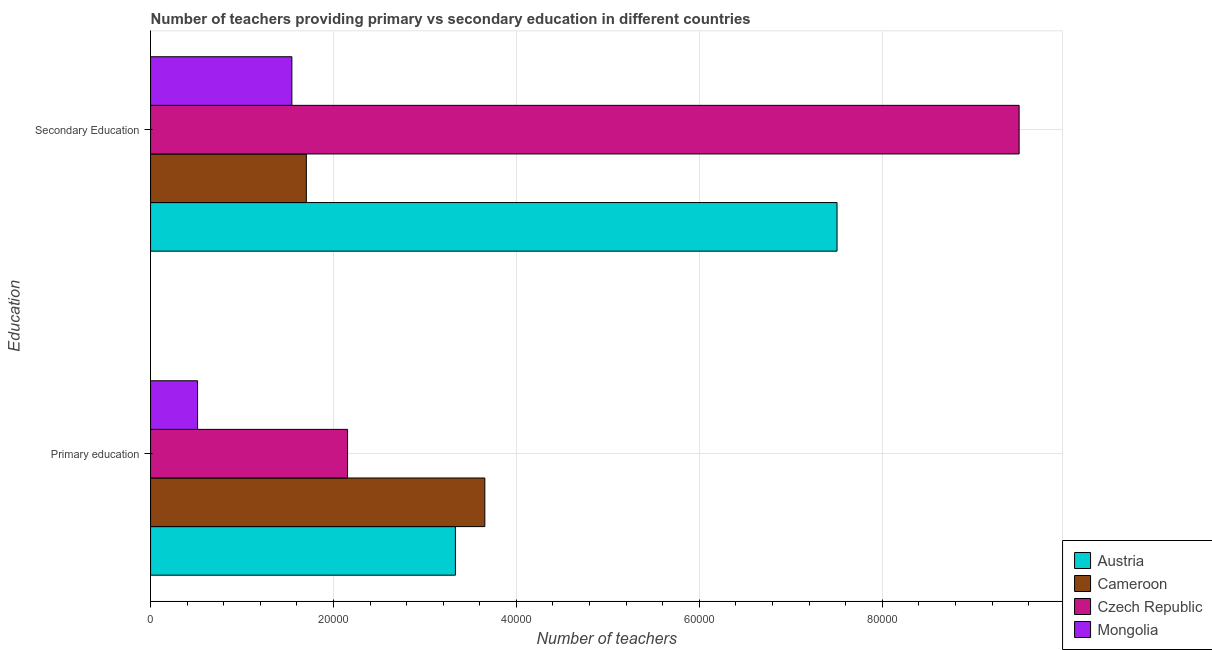How many different coloured bars are there?
Offer a terse response. 4. How many bars are there on the 2nd tick from the top?
Offer a very short reply. 4. How many bars are there on the 2nd tick from the bottom?
Make the answer very short. 4. What is the label of the 1st group of bars from the top?
Give a very brief answer. Secondary Education. What is the number of primary teachers in Czech Republic?
Provide a short and direct response. 2.15e+04. Across all countries, what is the maximum number of primary teachers?
Give a very brief answer. 3.65e+04. Across all countries, what is the minimum number of secondary teachers?
Provide a short and direct response. 1.54e+04. In which country was the number of primary teachers maximum?
Keep it short and to the point. Cameroon. In which country was the number of secondary teachers minimum?
Make the answer very short. Mongolia. What is the total number of primary teachers in the graph?
Provide a short and direct response. 9.66e+04. What is the difference between the number of secondary teachers in Mongolia and that in Czech Republic?
Ensure brevity in your answer.  -7.95e+04. What is the difference between the number of secondary teachers in Austria and the number of primary teachers in Mongolia?
Give a very brief answer. 6.99e+04. What is the average number of secondary teachers per country?
Provide a succinct answer. 5.06e+04. What is the difference between the number of primary teachers and number of secondary teachers in Mongolia?
Provide a succinct answer. -1.03e+04. In how many countries, is the number of secondary teachers greater than 36000 ?
Offer a terse response. 2. What is the ratio of the number of secondary teachers in Austria to that in Mongolia?
Offer a very short reply. 4.86. Is the number of primary teachers in Czech Republic less than that in Mongolia?
Provide a short and direct response. No. What does the 3rd bar from the top in Primary education represents?
Offer a very short reply. Cameroon. What does the 1st bar from the bottom in Primary education represents?
Ensure brevity in your answer.  Austria. What is the difference between two consecutive major ticks on the X-axis?
Make the answer very short. 2.00e+04. Are the values on the major ticks of X-axis written in scientific E-notation?
Offer a very short reply. No. How many legend labels are there?
Make the answer very short. 4. How are the legend labels stacked?
Give a very brief answer. Vertical. What is the title of the graph?
Your answer should be very brief. Number of teachers providing primary vs secondary education in different countries. What is the label or title of the X-axis?
Keep it short and to the point. Number of teachers. What is the label or title of the Y-axis?
Make the answer very short. Education. What is the Number of teachers of Austria in Primary education?
Offer a terse response. 3.33e+04. What is the Number of teachers in Cameroon in Primary education?
Keep it short and to the point. 3.65e+04. What is the Number of teachers of Czech Republic in Primary education?
Give a very brief answer. 2.15e+04. What is the Number of teachers in Mongolia in Primary education?
Keep it short and to the point. 5140. What is the Number of teachers of Austria in Secondary Education?
Provide a succinct answer. 7.51e+04. What is the Number of teachers of Cameroon in Secondary Education?
Give a very brief answer. 1.70e+04. What is the Number of teachers of Czech Republic in Secondary Education?
Provide a short and direct response. 9.50e+04. What is the Number of teachers in Mongolia in Secondary Education?
Keep it short and to the point. 1.54e+04. Across all Education, what is the maximum Number of teachers in Austria?
Keep it short and to the point. 7.51e+04. Across all Education, what is the maximum Number of teachers of Cameroon?
Offer a very short reply. 3.65e+04. Across all Education, what is the maximum Number of teachers in Czech Republic?
Give a very brief answer. 9.50e+04. Across all Education, what is the maximum Number of teachers in Mongolia?
Your answer should be compact. 1.54e+04. Across all Education, what is the minimum Number of teachers in Austria?
Your answer should be very brief. 3.33e+04. Across all Education, what is the minimum Number of teachers in Cameroon?
Offer a terse response. 1.70e+04. Across all Education, what is the minimum Number of teachers of Czech Republic?
Your response must be concise. 2.15e+04. Across all Education, what is the minimum Number of teachers in Mongolia?
Offer a very short reply. 5140. What is the total Number of teachers in Austria in the graph?
Give a very brief answer. 1.08e+05. What is the total Number of teachers in Cameroon in the graph?
Your answer should be very brief. 5.36e+04. What is the total Number of teachers in Czech Republic in the graph?
Your response must be concise. 1.17e+05. What is the total Number of teachers of Mongolia in the graph?
Ensure brevity in your answer.  2.06e+04. What is the difference between the Number of teachers of Austria in Primary education and that in Secondary Education?
Offer a terse response. -4.17e+04. What is the difference between the Number of teachers of Cameroon in Primary education and that in Secondary Education?
Give a very brief answer. 1.95e+04. What is the difference between the Number of teachers in Czech Republic in Primary education and that in Secondary Education?
Your response must be concise. -7.34e+04. What is the difference between the Number of teachers of Mongolia in Primary education and that in Secondary Education?
Provide a short and direct response. -1.03e+04. What is the difference between the Number of teachers in Austria in Primary education and the Number of teachers in Cameroon in Secondary Education?
Offer a very short reply. 1.63e+04. What is the difference between the Number of teachers in Austria in Primary education and the Number of teachers in Czech Republic in Secondary Education?
Ensure brevity in your answer.  -6.16e+04. What is the difference between the Number of teachers of Austria in Primary education and the Number of teachers of Mongolia in Secondary Education?
Keep it short and to the point. 1.79e+04. What is the difference between the Number of teachers in Cameroon in Primary education and the Number of teachers in Czech Republic in Secondary Education?
Your answer should be compact. -5.84e+04. What is the difference between the Number of teachers in Cameroon in Primary education and the Number of teachers in Mongolia in Secondary Education?
Keep it short and to the point. 2.11e+04. What is the difference between the Number of teachers of Czech Republic in Primary education and the Number of teachers of Mongolia in Secondary Education?
Your response must be concise. 6089. What is the average Number of teachers of Austria per Education?
Offer a terse response. 5.42e+04. What is the average Number of teachers in Cameroon per Education?
Your answer should be very brief. 2.68e+04. What is the average Number of teachers in Czech Republic per Education?
Provide a short and direct response. 5.83e+04. What is the average Number of teachers in Mongolia per Education?
Give a very brief answer. 1.03e+04. What is the difference between the Number of teachers in Austria and Number of teachers in Cameroon in Primary education?
Your response must be concise. -3218. What is the difference between the Number of teachers in Austria and Number of teachers in Czech Republic in Primary education?
Give a very brief answer. 1.18e+04. What is the difference between the Number of teachers of Austria and Number of teachers of Mongolia in Primary education?
Keep it short and to the point. 2.82e+04. What is the difference between the Number of teachers of Cameroon and Number of teachers of Czech Republic in Primary education?
Offer a terse response. 1.50e+04. What is the difference between the Number of teachers of Cameroon and Number of teachers of Mongolia in Primary education?
Offer a terse response. 3.14e+04. What is the difference between the Number of teachers in Czech Republic and Number of teachers in Mongolia in Primary education?
Ensure brevity in your answer.  1.64e+04. What is the difference between the Number of teachers of Austria and Number of teachers of Cameroon in Secondary Education?
Make the answer very short. 5.80e+04. What is the difference between the Number of teachers in Austria and Number of teachers in Czech Republic in Secondary Education?
Your response must be concise. -1.99e+04. What is the difference between the Number of teachers in Austria and Number of teachers in Mongolia in Secondary Education?
Provide a succinct answer. 5.96e+04. What is the difference between the Number of teachers of Cameroon and Number of teachers of Czech Republic in Secondary Education?
Keep it short and to the point. -7.79e+04. What is the difference between the Number of teachers of Cameroon and Number of teachers of Mongolia in Secondary Education?
Give a very brief answer. 1582. What is the difference between the Number of teachers in Czech Republic and Number of teachers in Mongolia in Secondary Education?
Ensure brevity in your answer.  7.95e+04. What is the ratio of the Number of teachers in Austria in Primary education to that in Secondary Education?
Keep it short and to the point. 0.44. What is the ratio of the Number of teachers in Cameroon in Primary education to that in Secondary Education?
Your answer should be compact. 2.15. What is the ratio of the Number of teachers in Czech Republic in Primary education to that in Secondary Education?
Give a very brief answer. 0.23. What is the ratio of the Number of teachers of Mongolia in Primary education to that in Secondary Education?
Offer a terse response. 0.33. What is the difference between the highest and the second highest Number of teachers in Austria?
Give a very brief answer. 4.17e+04. What is the difference between the highest and the second highest Number of teachers of Cameroon?
Offer a terse response. 1.95e+04. What is the difference between the highest and the second highest Number of teachers in Czech Republic?
Give a very brief answer. 7.34e+04. What is the difference between the highest and the second highest Number of teachers of Mongolia?
Offer a very short reply. 1.03e+04. What is the difference between the highest and the lowest Number of teachers of Austria?
Your answer should be very brief. 4.17e+04. What is the difference between the highest and the lowest Number of teachers in Cameroon?
Offer a very short reply. 1.95e+04. What is the difference between the highest and the lowest Number of teachers of Czech Republic?
Your answer should be very brief. 7.34e+04. What is the difference between the highest and the lowest Number of teachers in Mongolia?
Your response must be concise. 1.03e+04. 